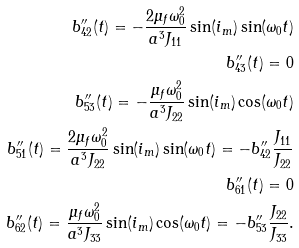Convert formula to latex. <formula><loc_0><loc_0><loc_500><loc_500>b ^ { \prime \prime } _ { 4 2 } ( t ) = - \frac { 2 \mu _ { f } \omega _ { 0 } ^ { 2 } } { a ^ { 3 } J _ { 1 1 } } \sin ( i _ { m } ) \sin ( \omega _ { 0 } t ) \\ b ^ { \prime \prime } _ { 4 3 } ( t ) = 0 \\ b ^ { \prime \prime } _ { 5 3 } ( t ) = - \frac { \mu _ { f } \omega _ { 0 } ^ { 2 } } { a ^ { 3 } J _ { 2 2 } } \sin ( i _ { m } ) \cos ( \omega _ { 0 } t ) \\ b ^ { \prime \prime } _ { 5 1 } ( t ) = \frac { 2 \mu _ { f } \omega _ { 0 } ^ { 2 } } { a ^ { 3 } J _ { 2 2 } } \sin ( i _ { m } ) \sin ( \omega _ { 0 } t ) = - b ^ { \prime \prime } _ { 4 2 } \frac { J _ { 1 1 } } { J _ { 2 2 } } \\ b ^ { \prime \prime } _ { 6 1 } ( t ) = 0 \\ b ^ { \prime \prime } _ { 6 2 } ( t ) = \frac { \mu _ { f } \omega _ { 0 } ^ { 2 } } { a ^ { 3 } J _ { 3 3 } } \sin ( i _ { m } ) \cos ( \omega _ { 0 } t ) = - b ^ { \prime \prime } _ { 5 3 } \frac { J _ { 2 2 } } { J _ { 3 3 } } .</formula> 